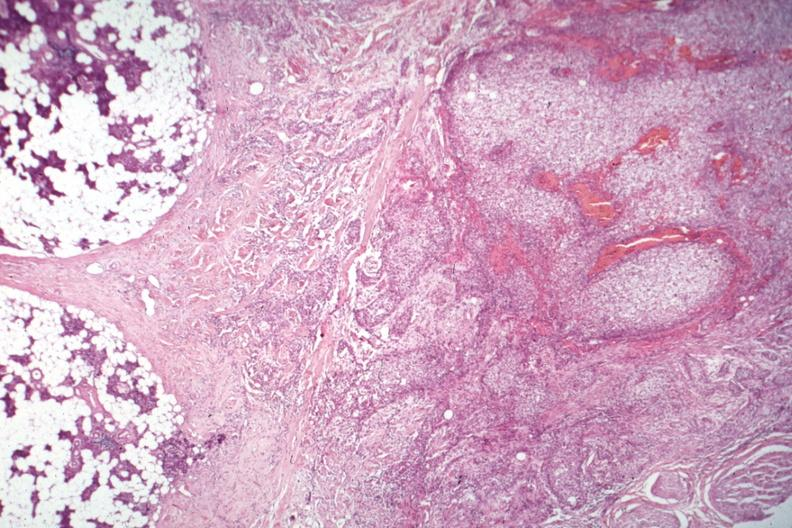what is present?
Answer the question using a single word or phrase. Parathyroid 